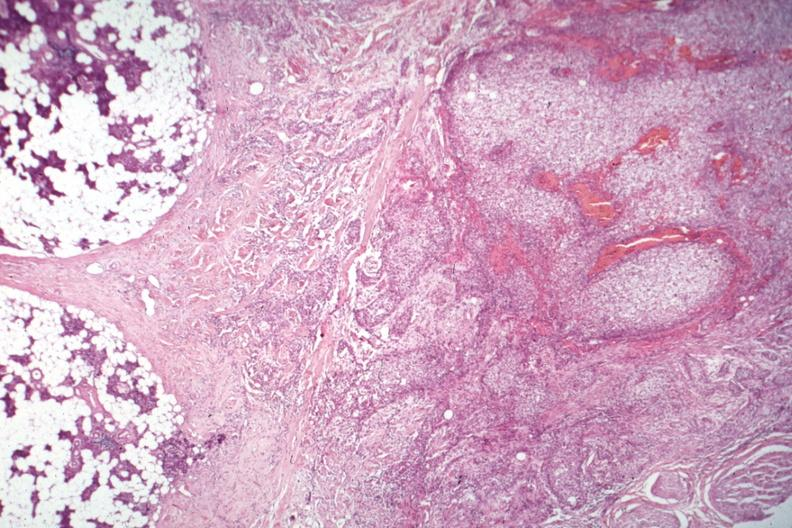what is present?
Answer the question using a single word or phrase. Parathyroid 